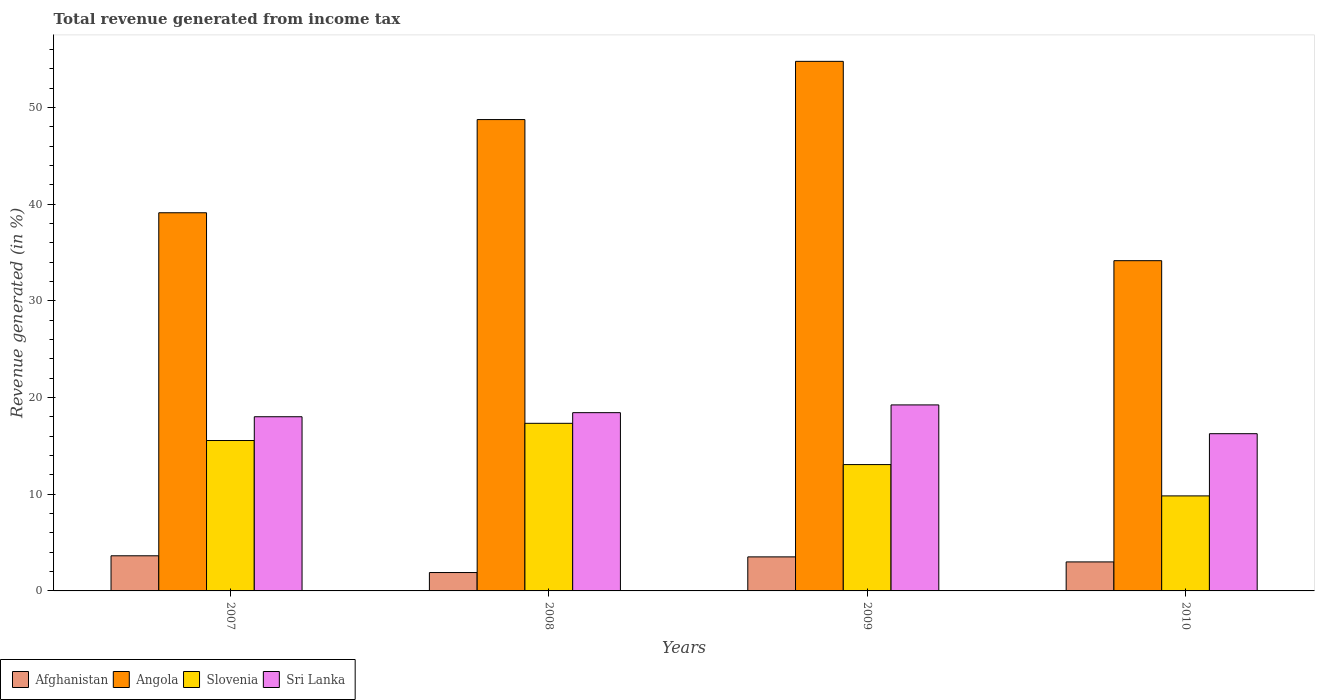How many groups of bars are there?
Offer a very short reply. 4. Are the number of bars on each tick of the X-axis equal?
Make the answer very short. Yes. How many bars are there on the 4th tick from the left?
Keep it short and to the point. 4. How many bars are there on the 3rd tick from the right?
Your answer should be compact. 4. What is the label of the 2nd group of bars from the left?
Offer a terse response. 2008. In how many cases, is the number of bars for a given year not equal to the number of legend labels?
Give a very brief answer. 0. What is the total revenue generated in Afghanistan in 2009?
Your answer should be very brief. 3.52. Across all years, what is the maximum total revenue generated in Afghanistan?
Provide a short and direct response. 3.63. Across all years, what is the minimum total revenue generated in Angola?
Provide a succinct answer. 34.15. In which year was the total revenue generated in Afghanistan minimum?
Your answer should be very brief. 2008. What is the total total revenue generated in Angola in the graph?
Provide a succinct answer. 176.76. What is the difference between the total revenue generated in Sri Lanka in 2007 and that in 2008?
Offer a terse response. -0.42. What is the difference between the total revenue generated in Sri Lanka in 2008 and the total revenue generated in Angola in 2009?
Ensure brevity in your answer.  -36.33. What is the average total revenue generated in Angola per year?
Offer a very short reply. 44.19. In the year 2010, what is the difference between the total revenue generated in Slovenia and total revenue generated in Angola?
Keep it short and to the point. -24.32. What is the ratio of the total revenue generated in Afghanistan in 2007 to that in 2008?
Provide a short and direct response. 1.91. Is the difference between the total revenue generated in Slovenia in 2008 and 2010 greater than the difference between the total revenue generated in Angola in 2008 and 2010?
Your answer should be very brief. No. What is the difference between the highest and the second highest total revenue generated in Slovenia?
Make the answer very short. 1.78. What is the difference between the highest and the lowest total revenue generated in Slovenia?
Offer a terse response. 7.5. In how many years, is the total revenue generated in Afghanistan greater than the average total revenue generated in Afghanistan taken over all years?
Keep it short and to the point. 2. Is the sum of the total revenue generated in Slovenia in 2008 and 2010 greater than the maximum total revenue generated in Sri Lanka across all years?
Provide a short and direct response. Yes. Is it the case that in every year, the sum of the total revenue generated in Slovenia and total revenue generated in Sri Lanka is greater than the sum of total revenue generated in Afghanistan and total revenue generated in Angola?
Give a very brief answer. No. What does the 1st bar from the left in 2008 represents?
Offer a very short reply. Afghanistan. What does the 4th bar from the right in 2009 represents?
Offer a terse response. Afghanistan. Is it the case that in every year, the sum of the total revenue generated in Afghanistan and total revenue generated in Slovenia is greater than the total revenue generated in Angola?
Ensure brevity in your answer.  No. How many bars are there?
Your answer should be compact. 16. How many years are there in the graph?
Provide a succinct answer. 4. Are the values on the major ticks of Y-axis written in scientific E-notation?
Offer a very short reply. No. Does the graph contain grids?
Your answer should be compact. No. Where does the legend appear in the graph?
Ensure brevity in your answer.  Bottom left. How many legend labels are there?
Provide a succinct answer. 4. What is the title of the graph?
Your answer should be very brief. Total revenue generated from income tax. What is the label or title of the X-axis?
Keep it short and to the point. Years. What is the label or title of the Y-axis?
Give a very brief answer. Revenue generated (in %). What is the Revenue generated (in %) of Afghanistan in 2007?
Offer a terse response. 3.63. What is the Revenue generated (in %) in Angola in 2007?
Provide a succinct answer. 39.11. What is the Revenue generated (in %) in Slovenia in 2007?
Make the answer very short. 15.55. What is the Revenue generated (in %) in Sri Lanka in 2007?
Give a very brief answer. 18.01. What is the Revenue generated (in %) in Afghanistan in 2008?
Give a very brief answer. 1.9. What is the Revenue generated (in %) of Angola in 2008?
Your response must be concise. 48.74. What is the Revenue generated (in %) in Slovenia in 2008?
Ensure brevity in your answer.  17.33. What is the Revenue generated (in %) in Sri Lanka in 2008?
Provide a short and direct response. 18.43. What is the Revenue generated (in %) in Afghanistan in 2009?
Provide a succinct answer. 3.52. What is the Revenue generated (in %) in Angola in 2009?
Keep it short and to the point. 54.76. What is the Revenue generated (in %) in Slovenia in 2009?
Provide a succinct answer. 13.06. What is the Revenue generated (in %) in Sri Lanka in 2009?
Keep it short and to the point. 19.23. What is the Revenue generated (in %) of Afghanistan in 2010?
Make the answer very short. 3. What is the Revenue generated (in %) in Angola in 2010?
Make the answer very short. 34.15. What is the Revenue generated (in %) of Slovenia in 2010?
Your answer should be compact. 9.83. What is the Revenue generated (in %) in Sri Lanka in 2010?
Make the answer very short. 16.26. Across all years, what is the maximum Revenue generated (in %) of Afghanistan?
Offer a very short reply. 3.63. Across all years, what is the maximum Revenue generated (in %) in Angola?
Provide a succinct answer. 54.76. Across all years, what is the maximum Revenue generated (in %) in Slovenia?
Provide a short and direct response. 17.33. Across all years, what is the maximum Revenue generated (in %) of Sri Lanka?
Provide a succinct answer. 19.23. Across all years, what is the minimum Revenue generated (in %) of Afghanistan?
Keep it short and to the point. 1.9. Across all years, what is the minimum Revenue generated (in %) in Angola?
Your response must be concise. 34.15. Across all years, what is the minimum Revenue generated (in %) in Slovenia?
Provide a succinct answer. 9.83. Across all years, what is the minimum Revenue generated (in %) of Sri Lanka?
Offer a terse response. 16.26. What is the total Revenue generated (in %) in Afghanistan in the graph?
Keep it short and to the point. 12.05. What is the total Revenue generated (in %) of Angola in the graph?
Your answer should be compact. 176.76. What is the total Revenue generated (in %) of Slovenia in the graph?
Your answer should be very brief. 55.77. What is the total Revenue generated (in %) in Sri Lanka in the graph?
Keep it short and to the point. 71.94. What is the difference between the Revenue generated (in %) of Afghanistan in 2007 and that in 2008?
Ensure brevity in your answer.  1.73. What is the difference between the Revenue generated (in %) in Angola in 2007 and that in 2008?
Offer a terse response. -9.64. What is the difference between the Revenue generated (in %) of Slovenia in 2007 and that in 2008?
Ensure brevity in your answer.  -1.78. What is the difference between the Revenue generated (in %) in Sri Lanka in 2007 and that in 2008?
Offer a terse response. -0.42. What is the difference between the Revenue generated (in %) of Afghanistan in 2007 and that in 2009?
Keep it short and to the point. 0.11. What is the difference between the Revenue generated (in %) in Angola in 2007 and that in 2009?
Offer a very short reply. -15.66. What is the difference between the Revenue generated (in %) of Slovenia in 2007 and that in 2009?
Your response must be concise. 2.49. What is the difference between the Revenue generated (in %) in Sri Lanka in 2007 and that in 2009?
Provide a short and direct response. -1.22. What is the difference between the Revenue generated (in %) in Afghanistan in 2007 and that in 2010?
Your answer should be compact. 0.63. What is the difference between the Revenue generated (in %) of Angola in 2007 and that in 2010?
Your answer should be compact. 4.96. What is the difference between the Revenue generated (in %) in Slovenia in 2007 and that in 2010?
Your response must be concise. 5.73. What is the difference between the Revenue generated (in %) of Sri Lanka in 2007 and that in 2010?
Your answer should be compact. 1.75. What is the difference between the Revenue generated (in %) in Afghanistan in 2008 and that in 2009?
Provide a short and direct response. -1.62. What is the difference between the Revenue generated (in %) in Angola in 2008 and that in 2009?
Keep it short and to the point. -6.02. What is the difference between the Revenue generated (in %) of Slovenia in 2008 and that in 2009?
Offer a terse response. 4.27. What is the difference between the Revenue generated (in %) of Sri Lanka in 2008 and that in 2009?
Your answer should be compact. -0.8. What is the difference between the Revenue generated (in %) in Afghanistan in 2008 and that in 2010?
Your answer should be compact. -1.1. What is the difference between the Revenue generated (in %) in Angola in 2008 and that in 2010?
Offer a very short reply. 14.59. What is the difference between the Revenue generated (in %) of Slovenia in 2008 and that in 2010?
Your answer should be very brief. 7.5. What is the difference between the Revenue generated (in %) in Sri Lanka in 2008 and that in 2010?
Your response must be concise. 2.18. What is the difference between the Revenue generated (in %) in Afghanistan in 2009 and that in 2010?
Offer a very short reply. 0.52. What is the difference between the Revenue generated (in %) of Angola in 2009 and that in 2010?
Offer a terse response. 20.61. What is the difference between the Revenue generated (in %) in Slovenia in 2009 and that in 2010?
Your response must be concise. 3.24. What is the difference between the Revenue generated (in %) of Sri Lanka in 2009 and that in 2010?
Your response must be concise. 2.98. What is the difference between the Revenue generated (in %) in Afghanistan in 2007 and the Revenue generated (in %) in Angola in 2008?
Provide a short and direct response. -45.11. What is the difference between the Revenue generated (in %) in Afghanistan in 2007 and the Revenue generated (in %) in Slovenia in 2008?
Ensure brevity in your answer.  -13.7. What is the difference between the Revenue generated (in %) of Afghanistan in 2007 and the Revenue generated (in %) of Sri Lanka in 2008?
Keep it short and to the point. -14.8. What is the difference between the Revenue generated (in %) of Angola in 2007 and the Revenue generated (in %) of Slovenia in 2008?
Keep it short and to the point. 21.77. What is the difference between the Revenue generated (in %) in Angola in 2007 and the Revenue generated (in %) in Sri Lanka in 2008?
Give a very brief answer. 20.67. What is the difference between the Revenue generated (in %) of Slovenia in 2007 and the Revenue generated (in %) of Sri Lanka in 2008?
Provide a succinct answer. -2.88. What is the difference between the Revenue generated (in %) in Afghanistan in 2007 and the Revenue generated (in %) in Angola in 2009?
Your response must be concise. -51.13. What is the difference between the Revenue generated (in %) of Afghanistan in 2007 and the Revenue generated (in %) of Slovenia in 2009?
Offer a terse response. -9.43. What is the difference between the Revenue generated (in %) in Afghanistan in 2007 and the Revenue generated (in %) in Sri Lanka in 2009?
Offer a terse response. -15.6. What is the difference between the Revenue generated (in %) in Angola in 2007 and the Revenue generated (in %) in Slovenia in 2009?
Provide a short and direct response. 26.04. What is the difference between the Revenue generated (in %) of Angola in 2007 and the Revenue generated (in %) of Sri Lanka in 2009?
Keep it short and to the point. 19.87. What is the difference between the Revenue generated (in %) in Slovenia in 2007 and the Revenue generated (in %) in Sri Lanka in 2009?
Keep it short and to the point. -3.68. What is the difference between the Revenue generated (in %) in Afghanistan in 2007 and the Revenue generated (in %) in Angola in 2010?
Keep it short and to the point. -30.52. What is the difference between the Revenue generated (in %) in Afghanistan in 2007 and the Revenue generated (in %) in Slovenia in 2010?
Keep it short and to the point. -6.19. What is the difference between the Revenue generated (in %) of Afghanistan in 2007 and the Revenue generated (in %) of Sri Lanka in 2010?
Your answer should be very brief. -12.63. What is the difference between the Revenue generated (in %) in Angola in 2007 and the Revenue generated (in %) in Slovenia in 2010?
Ensure brevity in your answer.  29.28. What is the difference between the Revenue generated (in %) in Angola in 2007 and the Revenue generated (in %) in Sri Lanka in 2010?
Your answer should be compact. 22.85. What is the difference between the Revenue generated (in %) in Slovenia in 2007 and the Revenue generated (in %) in Sri Lanka in 2010?
Offer a very short reply. -0.7. What is the difference between the Revenue generated (in %) in Afghanistan in 2008 and the Revenue generated (in %) in Angola in 2009?
Offer a very short reply. -52.86. What is the difference between the Revenue generated (in %) in Afghanistan in 2008 and the Revenue generated (in %) in Slovenia in 2009?
Your answer should be compact. -11.16. What is the difference between the Revenue generated (in %) in Afghanistan in 2008 and the Revenue generated (in %) in Sri Lanka in 2009?
Give a very brief answer. -17.33. What is the difference between the Revenue generated (in %) in Angola in 2008 and the Revenue generated (in %) in Slovenia in 2009?
Offer a very short reply. 35.68. What is the difference between the Revenue generated (in %) of Angola in 2008 and the Revenue generated (in %) of Sri Lanka in 2009?
Ensure brevity in your answer.  29.51. What is the difference between the Revenue generated (in %) of Slovenia in 2008 and the Revenue generated (in %) of Sri Lanka in 2009?
Offer a very short reply. -1.9. What is the difference between the Revenue generated (in %) in Afghanistan in 2008 and the Revenue generated (in %) in Angola in 2010?
Offer a terse response. -32.25. What is the difference between the Revenue generated (in %) of Afghanistan in 2008 and the Revenue generated (in %) of Slovenia in 2010?
Offer a terse response. -7.93. What is the difference between the Revenue generated (in %) in Afghanistan in 2008 and the Revenue generated (in %) in Sri Lanka in 2010?
Your response must be concise. -14.36. What is the difference between the Revenue generated (in %) in Angola in 2008 and the Revenue generated (in %) in Slovenia in 2010?
Provide a succinct answer. 38.92. What is the difference between the Revenue generated (in %) of Angola in 2008 and the Revenue generated (in %) of Sri Lanka in 2010?
Provide a short and direct response. 32.48. What is the difference between the Revenue generated (in %) in Slovenia in 2008 and the Revenue generated (in %) in Sri Lanka in 2010?
Ensure brevity in your answer.  1.07. What is the difference between the Revenue generated (in %) of Afghanistan in 2009 and the Revenue generated (in %) of Angola in 2010?
Offer a terse response. -30.63. What is the difference between the Revenue generated (in %) in Afghanistan in 2009 and the Revenue generated (in %) in Slovenia in 2010?
Ensure brevity in your answer.  -6.31. What is the difference between the Revenue generated (in %) in Afghanistan in 2009 and the Revenue generated (in %) in Sri Lanka in 2010?
Offer a terse response. -12.74. What is the difference between the Revenue generated (in %) of Angola in 2009 and the Revenue generated (in %) of Slovenia in 2010?
Your answer should be very brief. 44.94. What is the difference between the Revenue generated (in %) of Angola in 2009 and the Revenue generated (in %) of Sri Lanka in 2010?
Give a very brief answer. 38.5. What is the difference between the Revenue generated (in %) of Slovenia in 2009 and the Revenue generated (in %) of Sri Lanka in 2010?
Your answer should be compact. -3.19. What is the average Revenue generated (in %) in Afghanistan per year?
Your response must be concise. 3.01. What is the average Revenue generated (in %) of Angola per year?
Provide a short and direct response. 44.19. What is the average Revenue generated (in %) of Slovenia per year?
Provide a succinct answer. 13.94. What is the average Revenue generated (in %) in Sri Lanka per year?
Your answer should be compact. 17.98. In the year 2007, what is the difference between the Revenue generated (in %) of Afghanistan and Revenue generated (in %) of Angola?
Your answer should be very brief. -35.47. In the year 2007, what is the difference between the Revenue generated (in %) of Afghanistan and Revenue generated (in %) of Slovenia?
Ensure brevity in your answer.  -11.92. In the year 2007, what is the difference between the Revenue generated (in %) of Afghanistan and Revenue generated (in %) of Sri Lanka?
Make the answer very short. -14.38. In the year 2007, what is the difference between the Revenue generated (in %) of Angola and Revenue generated (in %) of Slovenia?
Your answer should be compact. 23.55. In the year 2007, what is the difference between the Revenue generated (in %) of Angola and Revenue generated (in %) of Sri Lanka?
Your response must be concise. 21.09. In the year 2007, what is the difference between the Revenue generated (in %) in Slovenia and Revenue generated (in %) in Sri Lanka?
Keep it short and to the point. -2.46. In the year 2008, what is the difference between the Revenue generated (in %) in Afghanistan and Revenue generated (in %) in Angola?
Your answer should be compact. -46.84. In the year 2008, what is the difference between the Revenue generated (in %) of Afghanistan and Revenue generated (in %) of Slovenia?
Provide a succinct answer. -15.43. In the year 2008, what is the difference between the Revenue generated (in %) in Afghanistan and Revenue generated (in %) in Sri Lanka?
Provide a short and direct response. -16.53. In the year 2008, what is the difference between the Revenue generated (in %) of Angola and Revenue generated (in %) of Slovenia?
Provide a short and direct response. 31.41. In the year 2008, what is the difference between the Revenue generated (in %) of Angola and Revenue generated (in %) of Sri Lanka?
Your response must be concise. 30.31. In the year 2008, what is the difference between the Revenue generated (in %) of Slovenia and Revenue generated (in %) of Sri Lanka?
Offer a very short reply. -1.1. In the year 2009, what is the difference between the Revenue generated (in %) in Afghanistan and Revenue generated (in %) in Angola?
Offer a terse response. -51.24. In the year 2009, what is the difference between the Revenue generated (in %) in Afghanistan and Revenue generated (in %) in Slovenia?
Ensure brevity in your answer.  -9.54. In the year 2009, what is the difference between the Revenue generated (in %) of Afghanistan and Revenue generated (in %) of Sri Lanka?
Offer a terse response. -15.71. In the year 2009, what is the difference between the Revenue generated (in %) of Angola and Revenue generated (in %) of Slovenia?
Keep it short and to the point. 41.7. In the year 2009, what is the difference between the Revenue generated (in %) in Angola and Revenue generated (in %) in Sri Lanka?
Offer a very short reply. 35.53. In the year 2009, what is the difference between the Revenue generated (in %) in Slovenia and Revenue generated (in %) in Sri Lanka?
Your answer should be very brief. -6.17. In the year 2010, what is the difference between the Revenue generated (in %) in Afghanistan and Revenue generated (in %) in Angola?
Give a very brief answer. -31.15. In the year 2010, what is the difference between the Revenue generated (in %) of Afghanistan and Revenue generated (in %) of Slovenia?
Provide a short and direct response. -6.83. In the year 2010, what is the difference between the Revenue generated (in %) in Afghanistan and Revenue generated (in %) in Sri Lanka?
Give a very brief answer. -13.26. In the year 2010, what is the difference between the Revenue generated (in %) in Angola and Revenue generated (in %) in Slovenia?
Give a very brief answer. 24.32. In the year 2010, what is the difference between the Revenue generated (in %) of Angola and Revenue generated (in %) of Sri Lanka?
Your answer should be compact. 17.89. In the year 2010, what is the difference between the Revenue generated (in %) of Slovenia and Revenue generated (in %) of Sri Lanka?
Offer a terse response. -6.43. What is the ratio of the Revenue generated (in %) in Afghanistan in 2007 to that in 2008?
Your response must be concise. 1.91. What is the ratio of the Revenue generated (in %) of Angola in 2007 to that in 2008?
Give a very brief answer. 0.8. What is the ratio of the Revenue generated (in %) in Slovenia in 2007 to that in 2008?
Keep it short and to the point. 0.9. What is the ratio of the Revenue generated (in %) of Sri Lanka in 2007 to that in 2008?
Your answer should be compact. 0.98. What is the ratio of the Revenue generated (in %) of Afghanistan in 2007 to that in 2009?
Offer a terse response. 1.03. What is the ratio of the Revenue generated (in %) in Angola in 2007 to that in 2009?
Offer a terse response. 0.71. What is the ratio of the Revenue generated (in %) in Slovenia in 2007 to that in 2009?
Make the answer very short. 1.19. What is the ratio of the Revenue generated (in %) in Sri Lanka in 2007 to that in 2009?
Keep it short and to the point. 0.94. What is the ratio of the Revenue generated (in %) in Afghanistan in 2007 to that in 2010?
Provide a succinct answer. 1.21. What is the ratio of the Revenue generated (in %) of Angola in 2007 to that in 2010?
Offer a very short reply. 1.15. What is the ratio of the Revenue generated (in %) in Slovenia in 2007 to that in 2010?
Your response must be concise. 1.58. What is the ratio of the Revenue generated (in %) in Sri Lanka in 2007 to that in 2010?
Provide a succinct answer. 1.11. What is the ratio of the Revenue generated (in %) of Afghanistan in 2008 to that in 2009?
Provide a short and direct response. 0.54. What is the ratio of the Revenue generated (in %) of Angola in 2008 to that in 2009?
Provide a succinct answer. 0.89. What is the ratio of the Revenue generated (in %) of Slovenia in 2008 to that in 2009?
Keep it short and to the point. 1.33. What is the ratio of the Revenue generated (in %) of Sri Lanka in 2008 to that in 2009?
Offer a very short reply. 0.96. What is the ratio of the Revenue generated (in %) of Afghanistan in 2008 to that in 2010?
Provide a succinct answer. 0.63. What is the ratio of the Revenue generated (in %) of Angola in 2008 to that in 2010?
Offer a terse response. 1.43. What is the ratio of the Revenue generated (in %) of Slovenia in 2008 to that in 2010?
Your response must be concise. 1.76. What is the ratio of the Revenue generated (in %) in Sri Lanka in 2008 to that in 2010?
Provide a succinct answer. 1.13. What is the ratio of the Revenue generated (in %) of Afghanistan in 2009 to that in 2010?
Make the answer very short. 1.17. What is the ratio of the Revenue generated (in %) of Angola in 2009 to that in 2010?
Ensure brevity in your answer.  1.6. What is the ratio of the Revenue generated (in %) of Slovenia in 2009 to that in 2010?
Offer a very short reply. 1.33. What is the ratio of the Revenue generated (in %) in Sri Lanka in 2009 to that in 2010?
Offer a terse response. 1.18. What is the difference between the highest and the second highest Revenue generated (in %) of Afghanistan?
Your answer should be very brief. 0.11. What is the difference between the highest and the second highest Revenue generated (in %) of Angola?
Keep it short and to the point. 6.02. What is the difference between the highest and the second highest Revenue generated (in %) in Slovenia?
Give a very brief answer. 1.78. What is the difference between the highest and the second highest Revenue generated (in %) in Sri Lanka?
Ensure brevity in your answer.  0.8. What is the difference between the highest and the lowest Revenue generated (in %) in Afghanistan?
Offer a very short reply. 1.73. What is the difference between the highest and the lowest Revenue generated (in %) of Angola?
Make the answer very short. 20.61. What is the difference between the highest and the lowest Revenue generated (in %) in Slovenia?
Keep it short and to the point. 7.5. What is the difference between the highest and the lowest Revenue generated (in %) in Sri Lanka?
Make the answer very short. 2.98. 